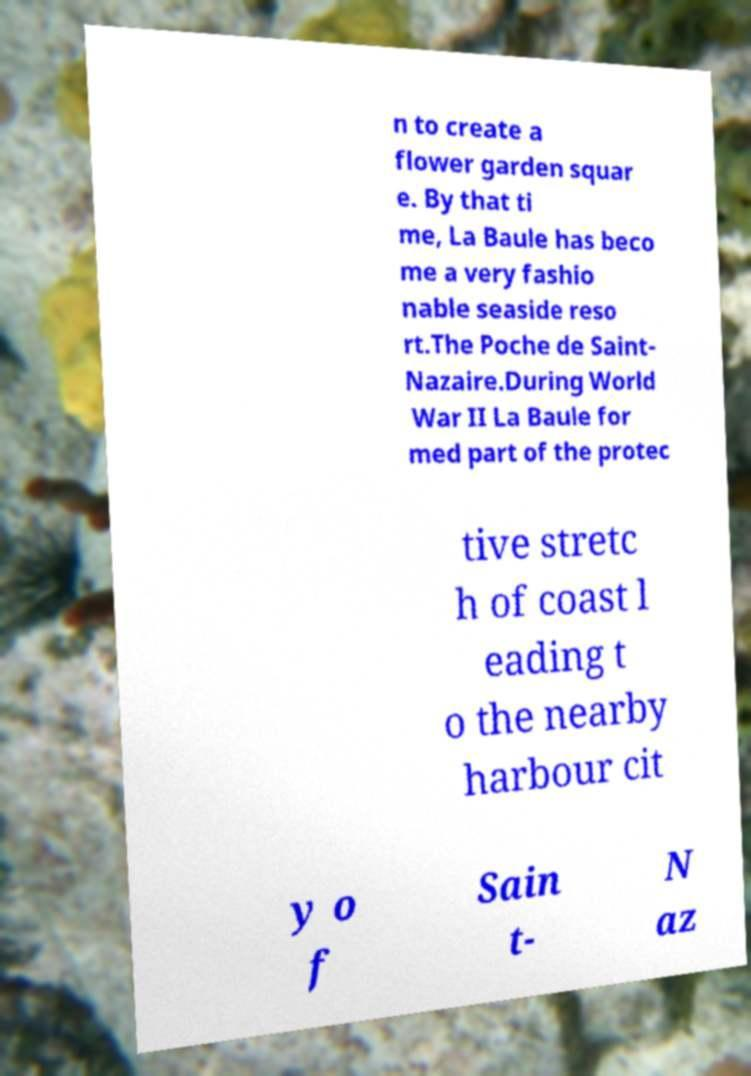Could you assist in decoding the text presented in this image and type it out clearly? n to create a flower garden squar e. By that ti me, La Baule has beco me a very fashio nable seaside reso rt.The Poche de Saint- Nazaire.During World War II La Baule for med part of the protec tive stretc h of coast l eading t o the nearby harbour cit y o f Sain t- N az 